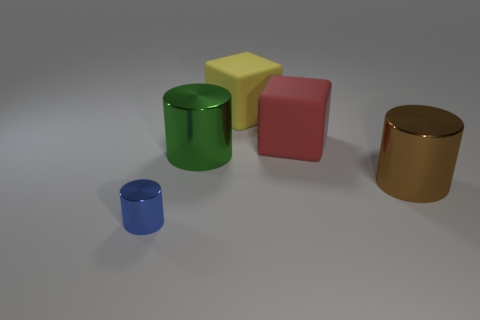How many other shiny things are the same shape as the brown object?
Keep it short and to the point. 2. What material is the tiny cylinder?
Offer a terse response. Metal. Are there the same number of big metal objects that are behind the yellow rubber cube and tiny green metallic blocks?
Provide a succinct answer. Yes. There is a red thing that is the same size as the yellow object; what is its shape?
Offer a very short reply. Cube. There is a yellow thing to the left of the brown thing; are there any large matte objects in front of it?
Your answer should be very brief. Yes. What number of large things are either green metallic cubes or brown metal cylinders?
Your response must be concise. 1. Are there any brown metal things of the same size as the green metallic thing?
Offer a very short reply. Yes. What number of shiny things are large green cylinders or small blue cylinders?
Your answer should be very brief. 2. What number of large things are there?
Your answer should be compact. 4. Is the material of the cylinder that is right of the large yellow thing the same as the cylinder on the left side of the big green cylinder?
Your answer should be very brief. Yes. 